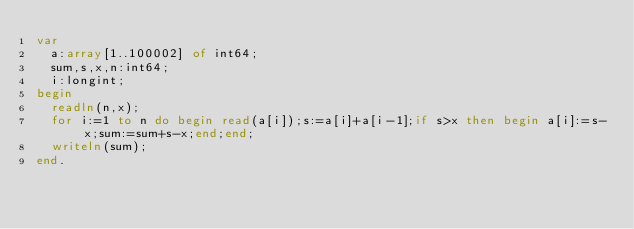<code> <loc_0><loc_0><loc_500><loc_500><_Pascal_>var
  a:array[1..100002] of int64;
  sum,s,x,n:int64;
  i:longint;
begin
  readln(n,x);
  for i:=1 to n do begin read(a[i]);s:=a[i]+a[i-1];if s>x then begin a[i]:=s-x;sum:=sum+s-x;end;end;
  writeln(sum);
end.</code> 